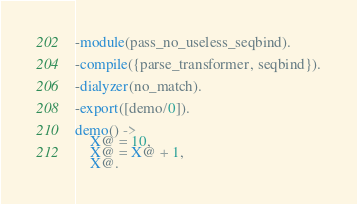<code> <loc_0><loc_0><loc_500><loc_500><_Erlang_>-module(pass_no_useless_seqbind).

-compile({parse_transformer, seqbind}).

-dialyzer(no_match).

-export([demo/0]).

demo() ->
    X@ = 10,
    X@ = X@ + 1,
    X@.
</code> 